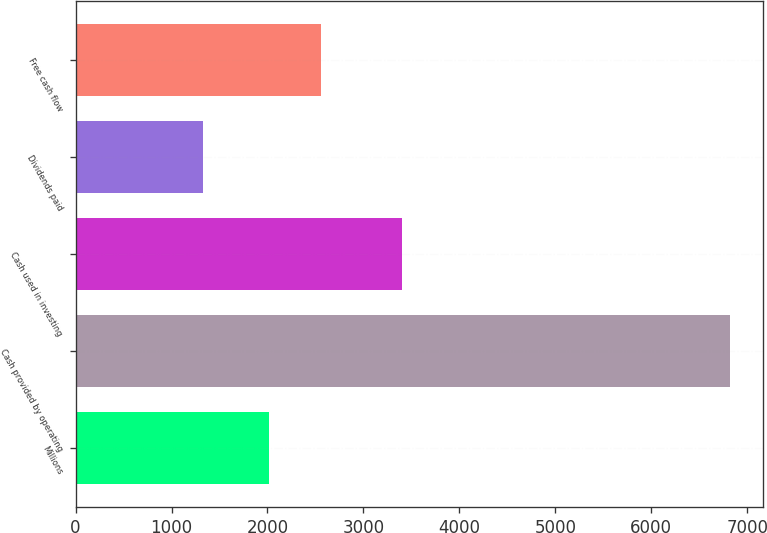Convert chart to OTSL. <chart><loc_0><loc_0><loc_500><loc_500><bar_chart><fcel>Millions<fcel>Cash provided by operating<fcel>Cash used in investing<fcel>Dividends paid<fcel>Free cash flow<nl><fcel>2013<fcel>6823<fcel>3405<fcel>1333<fcel>2562<nl></chart> 